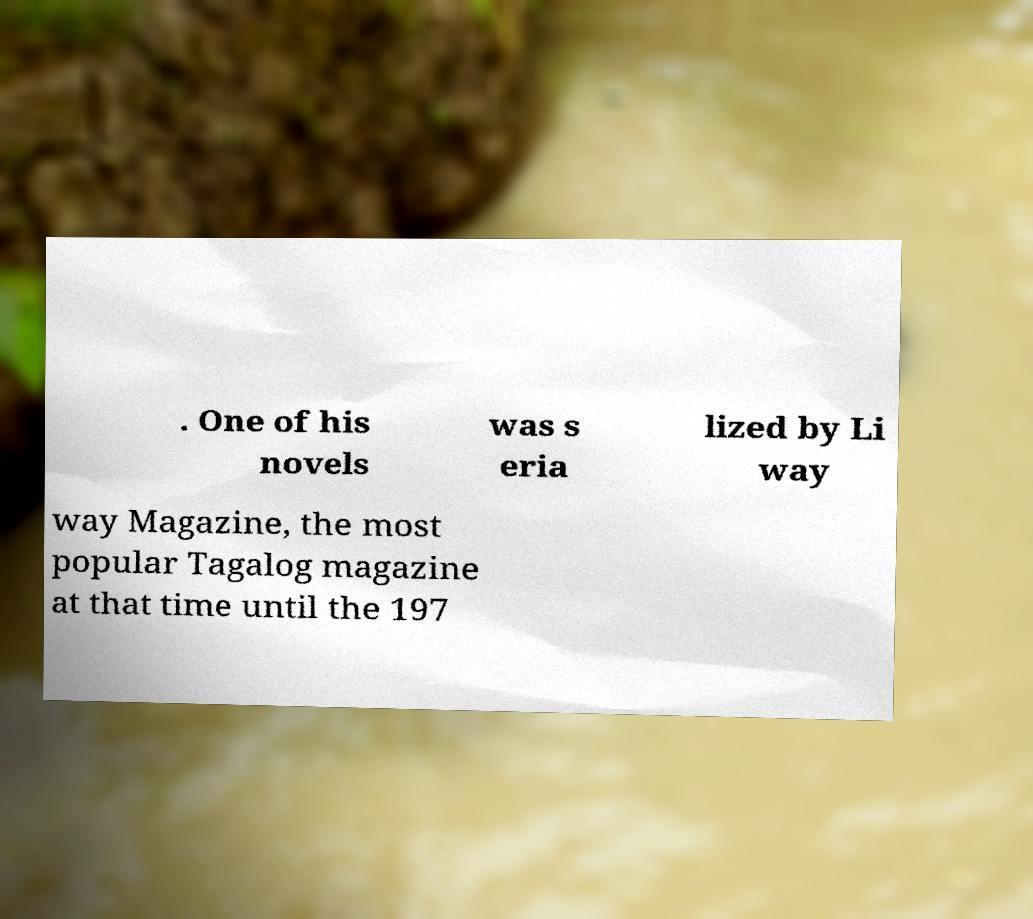Can you accurately transcribe the text from the provided image for me? . One of his novels was s eria lized by Li way way Magazine, the most popular Tagalog magazine at that time until the 197 